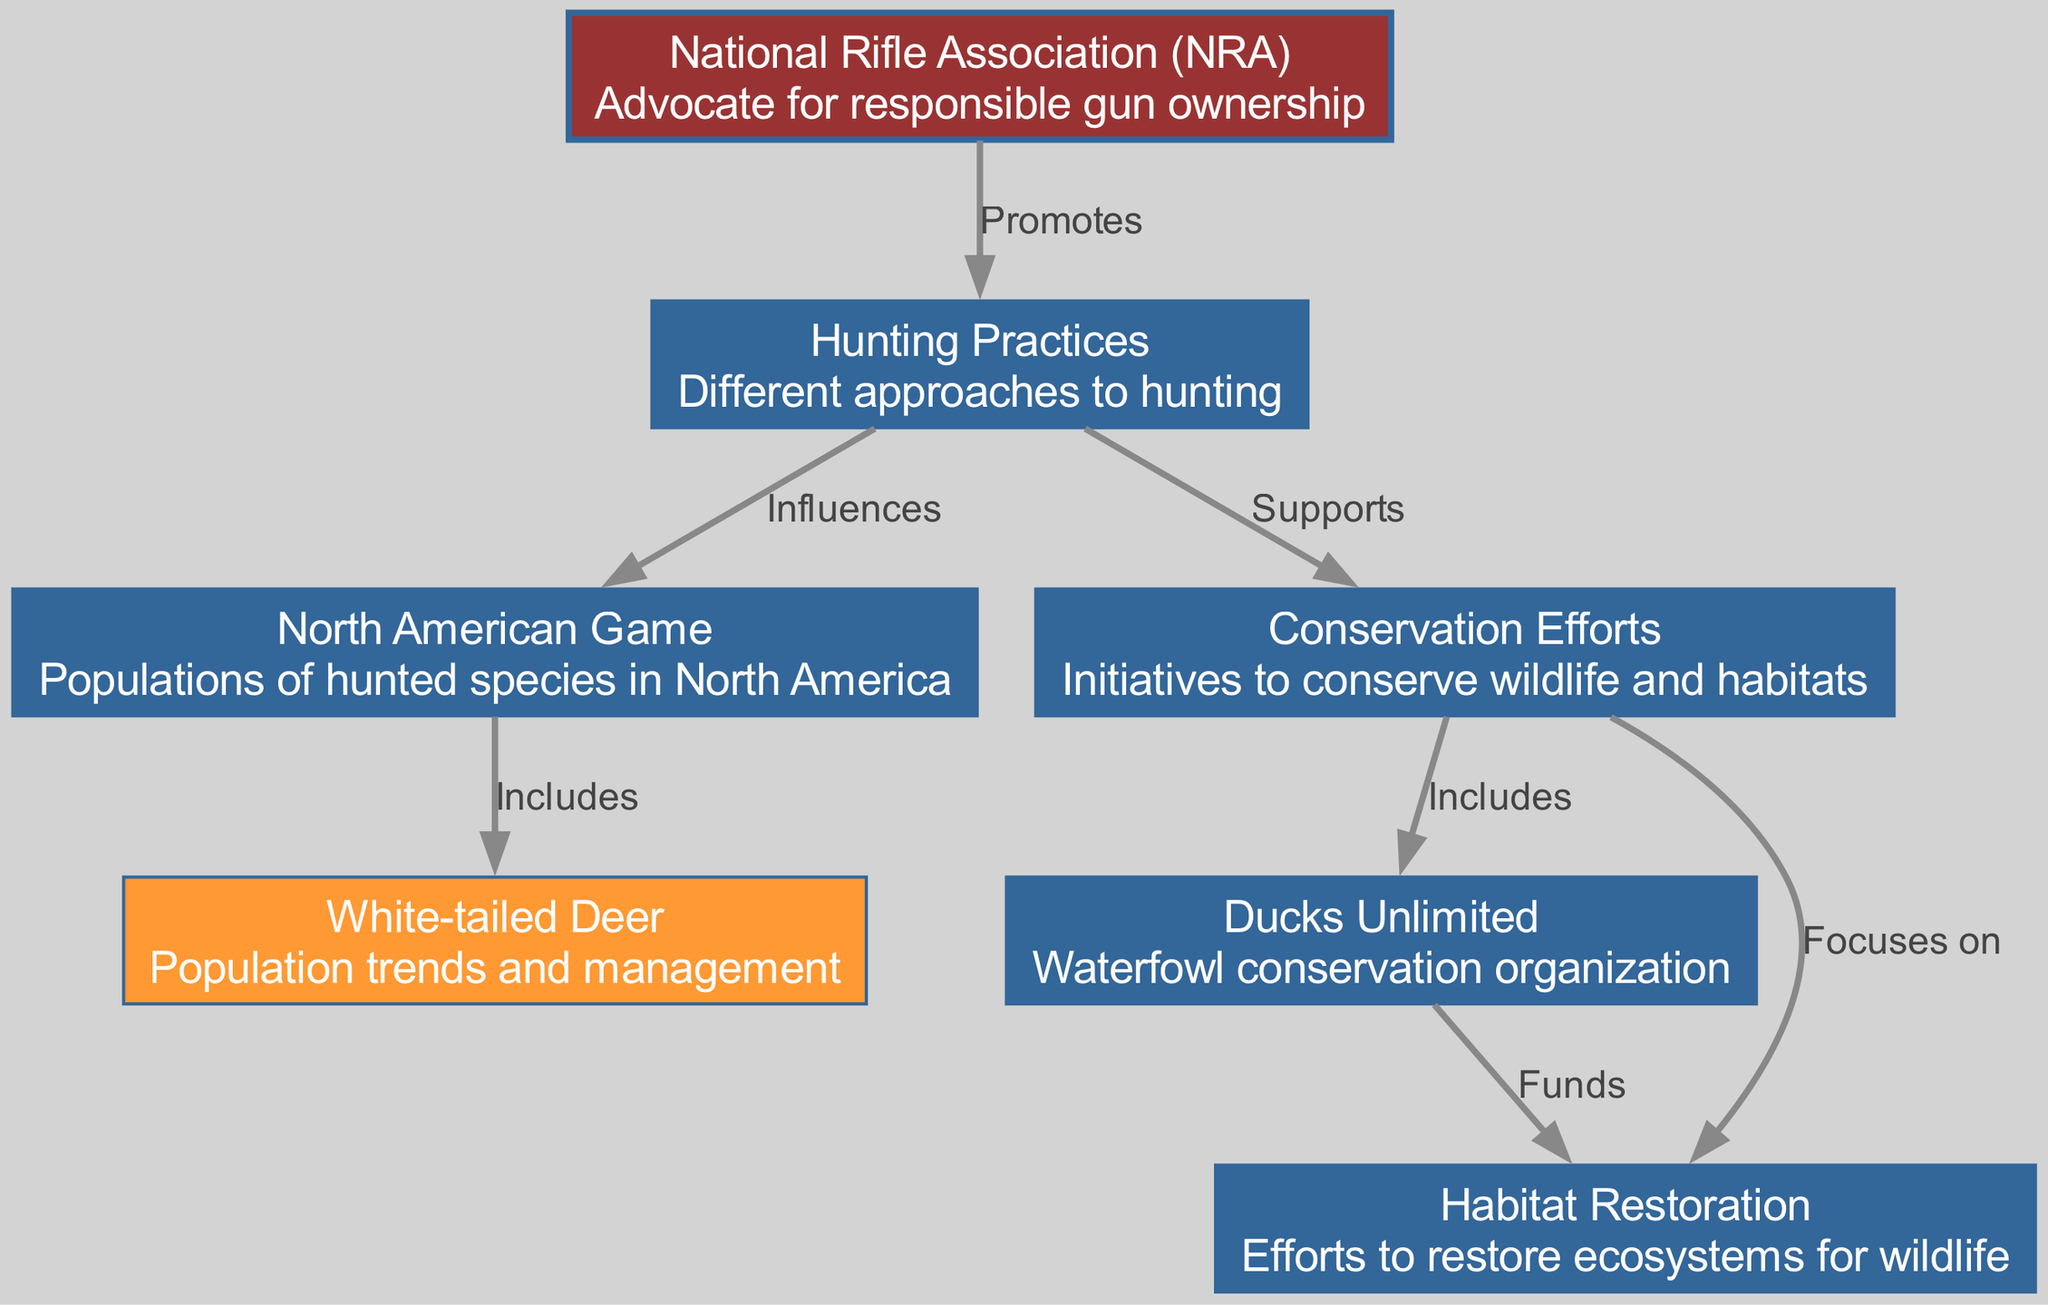What is represented at node 4? Node 4 represents "White-tailed Deer," which includes details about population trends and management.
Answer: White-tailed Deer How many nodes are present in the diagram? By counting the nodes listed, there are a total of seven distinct nodes in the diagram.
Answer: 7 What type of organization is Ducks Unlimited? The description associated with Ducks Unlimited indicates that it is a waterfowl conservation organization.
Answer: Waterfowl conservation organization What relationship does the NRA have with hunting practices? The diagram shows that the NRA promotes responsible gun ownership related to hunting practices, which suggests an advocacy role.
Answer: Promotes Which conservation efforts include habitat restoration? The edge from conservation efforts indicates that habitat restoration is a focus of wildlife conservation initiatives shown in the diagram.
Answer: Habitat Restoration What does the conservation effort "Ducks Unlimited" focus on? The link from conservation efforts to Ducks Unlimited implies that Ducks Unlimited is included in the wider category of conservation efforts to support wildlife.
Answer: Conservation efforts What happens to the flow from "Hunting Practices" to "Conservation Efforts"? The diagram shows that hunting practices support conservation efforts. This means that responsible hunting practices can provide backing or resources for conservation initiatives.
Answer: Supports Which node is highlighted in orange? In the diagram, the node specifically related to "White-tailed Deer" is highlighted in orange, indicating a special focus on this particular species.
Answer: White-tailed Deer 